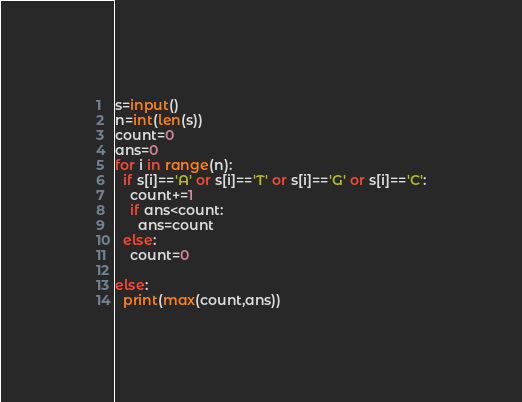Convert code to text. <code><loc_0><loc_0><loc_500><loc_500><_Python_>s=input()
n=int(len(s))
count=0
ans=0
for i in range(n):
  if s[i]=='A' or s[i]=='T' or s[i]=='G' or s[i]=='C':
    count+=1
    if ans<count:
      ans=count      
  else:
    count=0

else:
  print(max(count,ans))</code> 